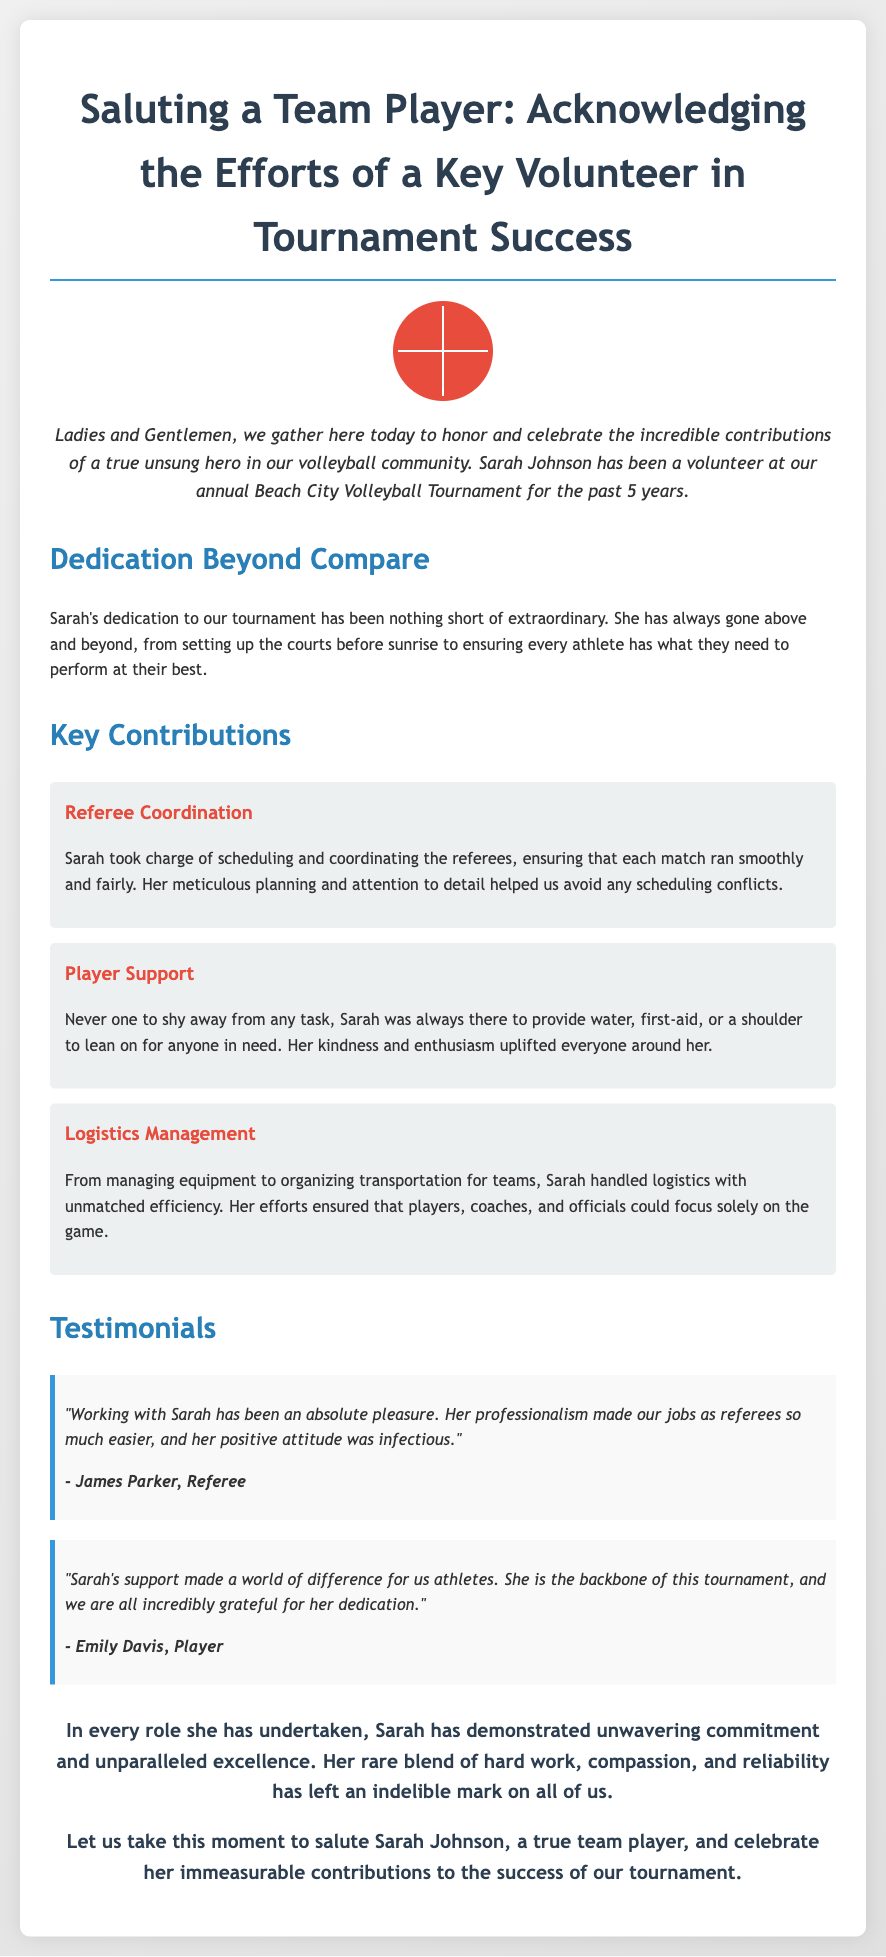What is the name of the key volunteer? The document specifically mentions Sarah Johnson as the key volunteer recognized in the eulogy.
Answer: Sarah Johnson How many years has Sarah volunteered? The text states that Sarah has been a volunteer for the past 5 years at the tournament.
Answer: 5 years What is one of Sarah's key contributions? The document lists various contributions, one being referee coordination, which highlights her responsibilities.
Answer: Referee Coordination Who provided a testimonial about Sarah? James Parker, a referee, is quoted in the document expressing his appreciation for Sarah's professionalism.
Answer: James Parker What was Sarah's role in player support? The document mentions that she provided water, first-aid, or a shoulder to lean on, illustrating her supportive nature.
Answer: Player support Which color scheme is used in the eulogy? The overall theme includes colors like white, red, and shades of blue in the styling of the document.
Answer: Red and blue What kind of event is the eulogy focused on? The eulogy is specifically tailored to recognize contributions to a volleyball tournament, highlighting Sarah's impact there.
Answer: Volleyball tournament What emotion does the eulogy primarily convey? The document reflects an atmosphere of appreciation and celebration for Sarah's efforts and dedication.
Answer: Appreciation 